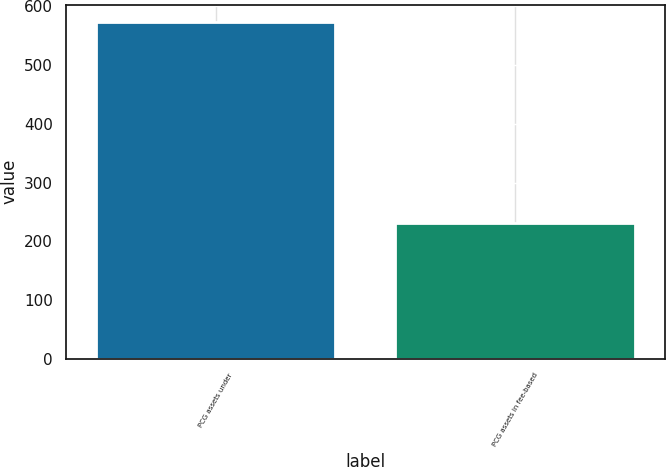Convert chart to OTSL. <chart><loc_0><loc_0><loc_500><loc_500><bar_chart><fcel>PCG assets under<fcel>PCG assets in fee-based<nl><fcel>574.1<fcel>231<nl></chart> 